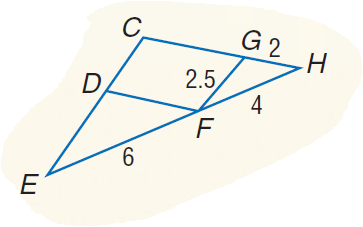Question: Find the perimeter of \triangle D E F if \triangle D E F \sim \triangle G F H.
Choices:
A. 12
B. 12.25
C. 12.5
D. 12.75
Answer with the letter. Answer: D 